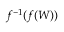<formula> <loc_0><loc_0><loc_500><loc_500>f ^ { - 1 } ( f ( W ) )</formula> 